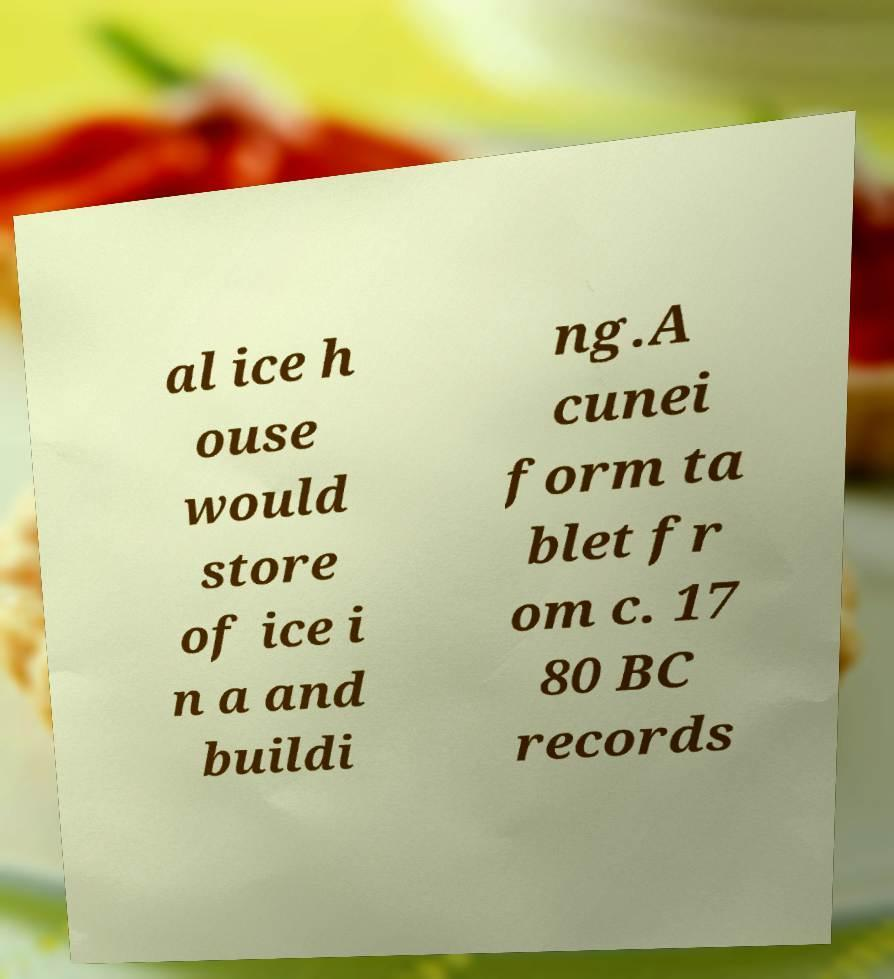Can you read and provide the text displayed in the image?This photo seems to have some interesting text. Can you extract and type it out for me? al ice h ouse would store of ice i n a and buildi ng.A cunei form ta blet fr om c. 17 80 BC records 